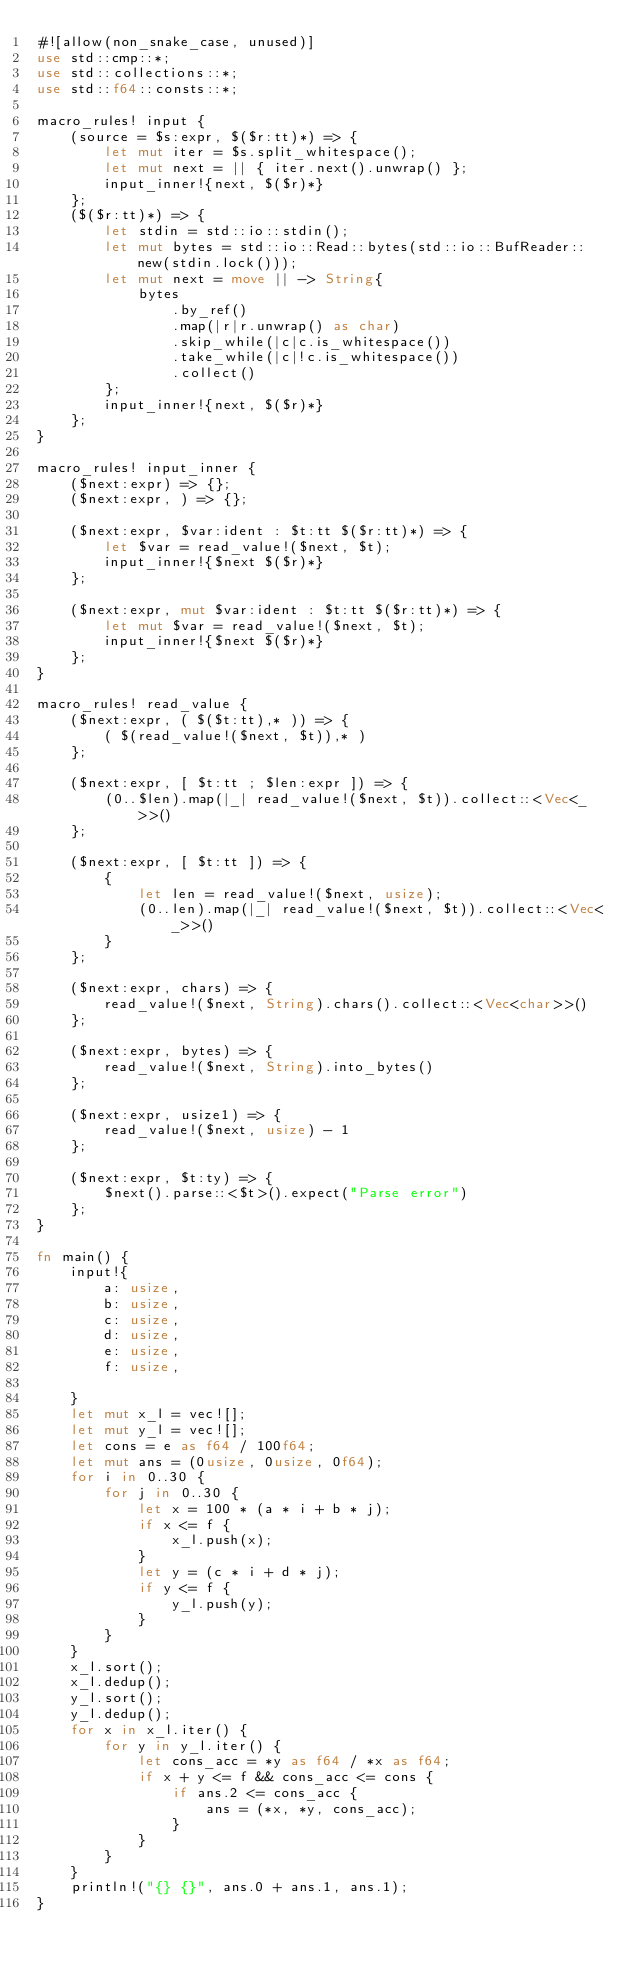Convert code to text. <code><loc_0><loc_0><loc_500><loc_500><_Rust_>#![allow(non_snake_case, unused)]
use std::cmp::*;
use std::collections::*;
use std::f64::consts::*;

macro_rules! input {
    (source = $s:expr, $($r:tt)*) => {
        let mut iter = $s.split_whitespace();
        let mut next = || { iter.next().unwrap() };
        input_inner!{next, $($r)*}
    };
    ($($r:tt)*) => {
        let stdin = std::io::stdin();
        let mut bytes = std::io::Read::bytes(std::io::BufReader::new(stdin.lock()));
        let mut next = move || -> String{
            bytes
                .by_ref()
                .map(|r|r.unwrap() as char)
                .skip_while(|c|c.is_whitespace())
                .take_while(|c|!c.is_whitespace())
                .collect()
        };
        input_inner!{next, $($r)*}
    };
}

macro_rules! input_inner {
    ($next:expr) => {};
    ($next:expr, ) => {};

    ($next:expr, $var:ident : $t:tt $($r:tt)*) => {
        let $var = read_value!($next, $t);
        input_inner!{$next $($r)*}
    };

    ($next:expr, mut $var:ident : $t:tt $($r:tt)*) => {
        let mut $var = read_value!($next, $t);
        input_inner!{$next $($r)*}
    };
}

macro_rules! read_value {
    ($next:expr, ( $($t:tt),* )) => {
        ( $(read_value!($next, $t)),* )
    };

    ($next:expr, [ $t:tt ; $len:expr ]) => {
        (0..$len).map(|_| read_value!($next, $t)).collect::<Vec<_>>()
    };

    ($next:expr, [ $t:tt ]) => {
        {
            let len = read_value!($next, usize);
            (0..len).map(|_| read_value!($next, $t)).collect::<Vec<_>>()
        }
    };

    ($next:expr, chars) => {
        read_value!($next, String).chars().collect::<Vec<char>>()
    };

    ($next:expr, bytes) => {
        read_value!($next, String).into_bytes()
    };

    ($next:expr, usize1) => {
        read_value!($next, usize) - 1
    };

    ($next:expr, $t:ty) => {
        $next().parse::<$t>().expect("Parse error")
    };
}

fn main() {
    input!{
        a: usize,
        b: usize,
        c: usize,
        d: usize,
        e: usize,
        f: usize,

    }
    let mut x_l = vec![];
    let mut y_l = vec![];
    let cons = e as f64 / 100f64;
    let mut ans = (0usize, 0usize, 0f64);
    for i in 0..30 {
        for j in 0..30 {
            let x = 100 * (a * i + b * j);
            if x <= f {
                x_l.push(x);
            }
            let y = (c * i + d * j);
            if y <= f {
                y_l.push(y);
            }
        }
    }
    x_l.sort();
    x_l.dedup();
    y_l.sort();
    y_l.dedup();
    for x in x_l.iter() {
        for y in y_l.iter() {
            let cons_acc = *y as f64 / *x as f64;
            if x + y <= f && cons_acc <= cons {
                if ans.2 <= cons_acc {
                    ans = (*x, *y, cons_acc);
                }
            }
        }
    }
    println!("{} {}", ans.0 + ans.1, ans.1);
}
</code> 